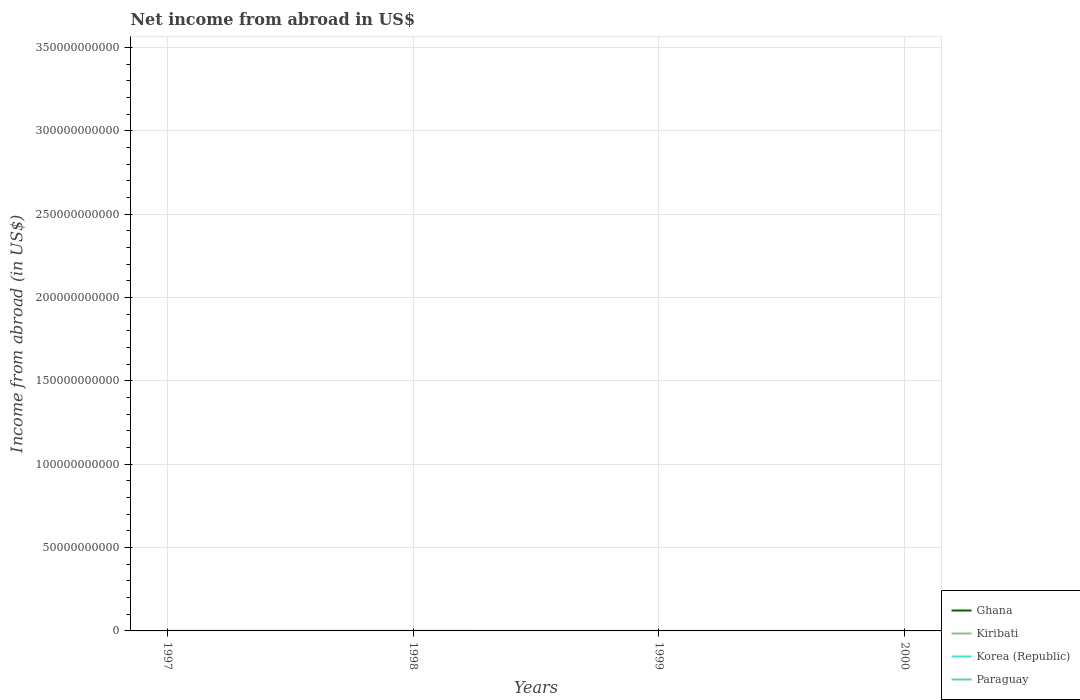How many different coloured lines are there?
Ensure brevity in your answer.  1. Does the line corresponding to Ghana intersect with the line corresponding to Paraguay?
Offer a very short reply. No. Is the number of lines equal to the number of legend labels?
Provide a succinct answer. No. Across all years, what is the maximum net income from abroad in Ghana?
Your response must be concise. 0. What is the total net income from abroad in Kiribati in the graph?
Provide a succinct answer. 3.34e+06. What is the difference between the highest and the second highest net income from abroad in Kiribati?
Offer a terse response. 1.78e+07. How many lines are there?
Provide a succinct answer. 1. How many years are there in the graph?
Make the answer very short. 4. What is the difference between two consecutive major ticks on the Y-axis?
Provide a succinct answer. 5.00e+1. Does the graph contain any zero values?
Provide a succinct answer. Yes. Where does the legend appear in the graph?
Your response must be concise. Bottom right. What is the title of the graph?
Provide a short and direct response. Net income from abroad in US$. Does "European Union" appear as one of the legend labels in the graph?
Give a very brief answer. No. What is the label or title of the X-axis?
Give a very brief answer. Years. What is the label or title of the Y-axis?
Ensure brevity in your answer.  Income from abroad (in US$). What is the Income from abroad (in US$) of Kiribati in 1997?
Give a very brief answer. 5.77e+07. What is the Income from abroad (in US$) in Paraguay in 1997?
Your answer should be compact. 0. What is the Income from abroad (in US$) of Kiribati in 1998?
Provide a short and direct response. 7.54e+07. What is the Income from abroad (in US$) in Paraguay in 1998?
Your response must be concise. 0. What is the Income from abroad (in US$) of Kiribati in 1999?
Keep it short and to the point. 6.39e+07. What is the Income from abroad (in US$) of Paraguay in 1999?
Your answer should be compact. 0. What is the Income from abroad (in US$) in Kiribati in 2000?
Provide a short and direct response. 7.21e+07. What is the Income from abroad (in US$) of Paraguay in 2000?
Your answer should be compact. 0. Across all years, what is the maximum Income from abroad (in US$) in Kiribati?
Provide a short and direct response. 7.54e+07. Across all years, what is the minimum Income from abroad (in US$) of Kiribati?
Offer a very short reply. 5.77e+07. What is the total Income from abroad (in US$) in Ghana in the graph?
Give a very brief answer. 0. What is the total Income from abroad (in US$) in Kiribati in the graph?
Offer a very short reply. 2.69e+08. What is the difference between the Income from abroad (in US$) of Kiribati in 1997 and that in 1998?
Offer a terse response. -1.78e+07. What is the difference between the Income from abroad (in US$) of Kiribati in 1997 and that in 1999?
Your answer should be very brief. -6.25e+06. What is the difference between the Income from abroad (in US$) of Kiribati in 1997 and that in 2000?
Ensure brevity in your answer.  -1.44e+07. What is the difference between the Income from abroad (in US$) in Kiribati in 1998 and that in 1999?
Your answer should be very brief. 1.15e+07. What is the difference between the Income from abroad (in US$) in Kiribati in 1998 and that in 2000?
Offer a very short reply. 3.34e+06. What is the difference between the Income from abroad (in US$) in Kiribati in 1999 and that in 2000?
Offer a very short reply. -8.17e+06. What is the average Income from abroad (in US$) of Ghana per year?
Provide a short and direct response. 0. What is the average Income from abroad (in US$) of Kiribati per year?
Keep it short and to the point. 6.73e+07. What is the average Income from abroad (in US$) in Korea (Republic) per year?
Give a very brief answer. 0. What is the ratio of the Income from abroad (in US$) of Kiribati in 1997 to that in 1998?
Offer a very short reply. 0.76. What is the ratio of the Income from abroad (in US$) in Kiribati in 1997 to that in 1999?
Your answer should be compact. 0.9. What is the ratio of the Income from abroad (in US$) of Kiribati in 1997 to that in 2000?
Provide a succinct answer. 0.8. What is the ratio of the Income from abroad (in US$) of Kiribati in 1998 to that in 1999?
Give a very brief answer. 1.18. What is the ratio of the Income from abroad (in US$) in Kiribati in 1998 to that in 2000?
Keep it short and to the point. 1.05. What is the ratio of the Income from abroad (in US$) of Kiribati in 1999 to that in 2000?
Offer a very short reply. 0.89. What is the difference between the highest and the second highest Income from abroad (in US$) of Kiribati?
Give a very brief answer. 3.34e+06. What is the difference between the highest and the lowest Income from abroad (in US$) in Kiribati?
Give a very brief answer. 1.78e+07. 